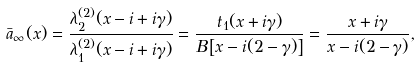<formula> <loc_0><loc_0><loc_500><loc_500>\bar { a } _ { \infty } ( x ) = \frac { \lambda _ { 2 } ^ { ( 2 ) } ( x - i + i \gamma ) } { \lambda _ { 1 } ^ { ( 2 ) } ( x - i + i \gamma ) } = \frac { t _ { 1 } ( x + i \gamma ) } { B \left [ x - i ( 2 - \gamma ) \right ] } = \frac { x + i \gamma } { x - i ( 2 - \gamma ) } ,</formula> 